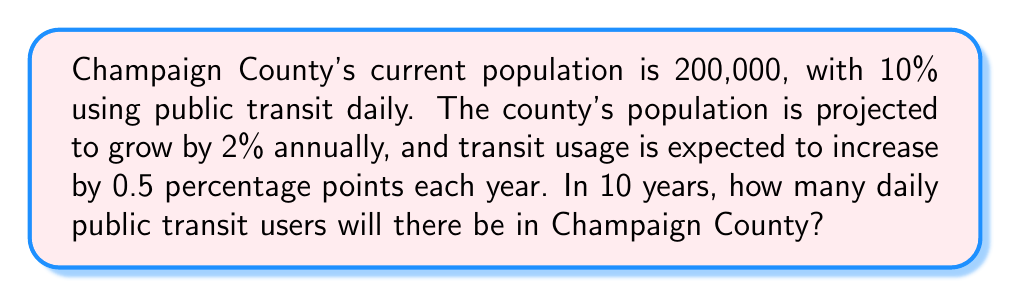What is the answer to this math problem? Let's approach this problem step-by-step:

1. Calculate the future population:
   - Current population: 200,000
   - Annual growth rate: 2% = 0.02
   - Time: 10 years
   - Future population = Current population $\times (1 + \text{growth rate})^{\text{years}}$
   $$200,000 \times (1 + 0.02)^{10} = 200,000 \times 1.218994 = 243,798.8$$

2. Calculate the future transit usage percentage:
   - Current usage: 10% = 0.10
   - Annual increase: 0.5 percentage points = 0.005
   - Future usage percentage = Current usage + (Annual increase $\times$ Years)
   $$0.10 + (0.005 \times 10) = 0.10 + 0.05 = 0.15 = 15\%$$

3. Calculate the number of daily transit users:
   - Future population: 243,798.8
   - Future usage percentage: 15% = 0.15
   - Daily transit users = Future population $\times$ Future usage percentage
   $$243,798.8 \times 0.15 = 36,569.82$$

4. Round to the nearest whole number, as we can't have fractional users:
   $$36,569.82 \approx 36,570$$
Answer: 36,570 daily public transit users 